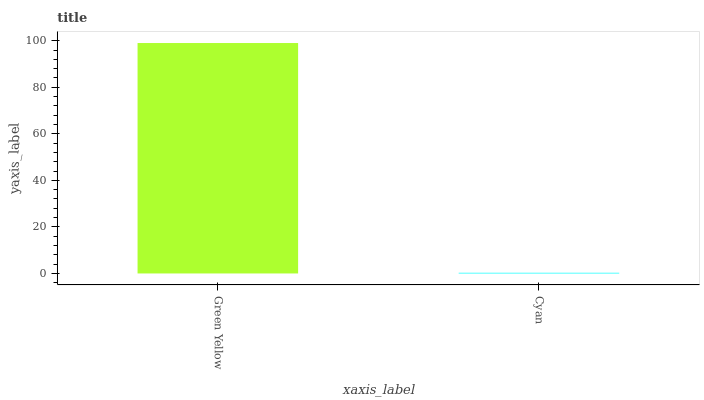Is Cyan the minimum?
Answer yes or no. Yes. Is Green Yellow the maximum?
Answer yes or no. Yes. Is Cyan the maximum?
Answer yes or no. No. Is Green Yellow greater than Cyan?
Answer yes or no. Yes. Is Cyan less than Green Yellow?
Answer yes or no. Yes. Is Cyan greater than Green Yellow?
Answer yes or no. No. Is Green Yellow less than Cyan?
Answer yes or no. No. Is Green Yellow the high median?
Answer yes or no. Yes. Is Cyan the low median?
Answer yes or no. Yes. Is Cyan the high median?
Answer yes or no. No. Is Green Yellow the low median?
Answer yes or no. No. 